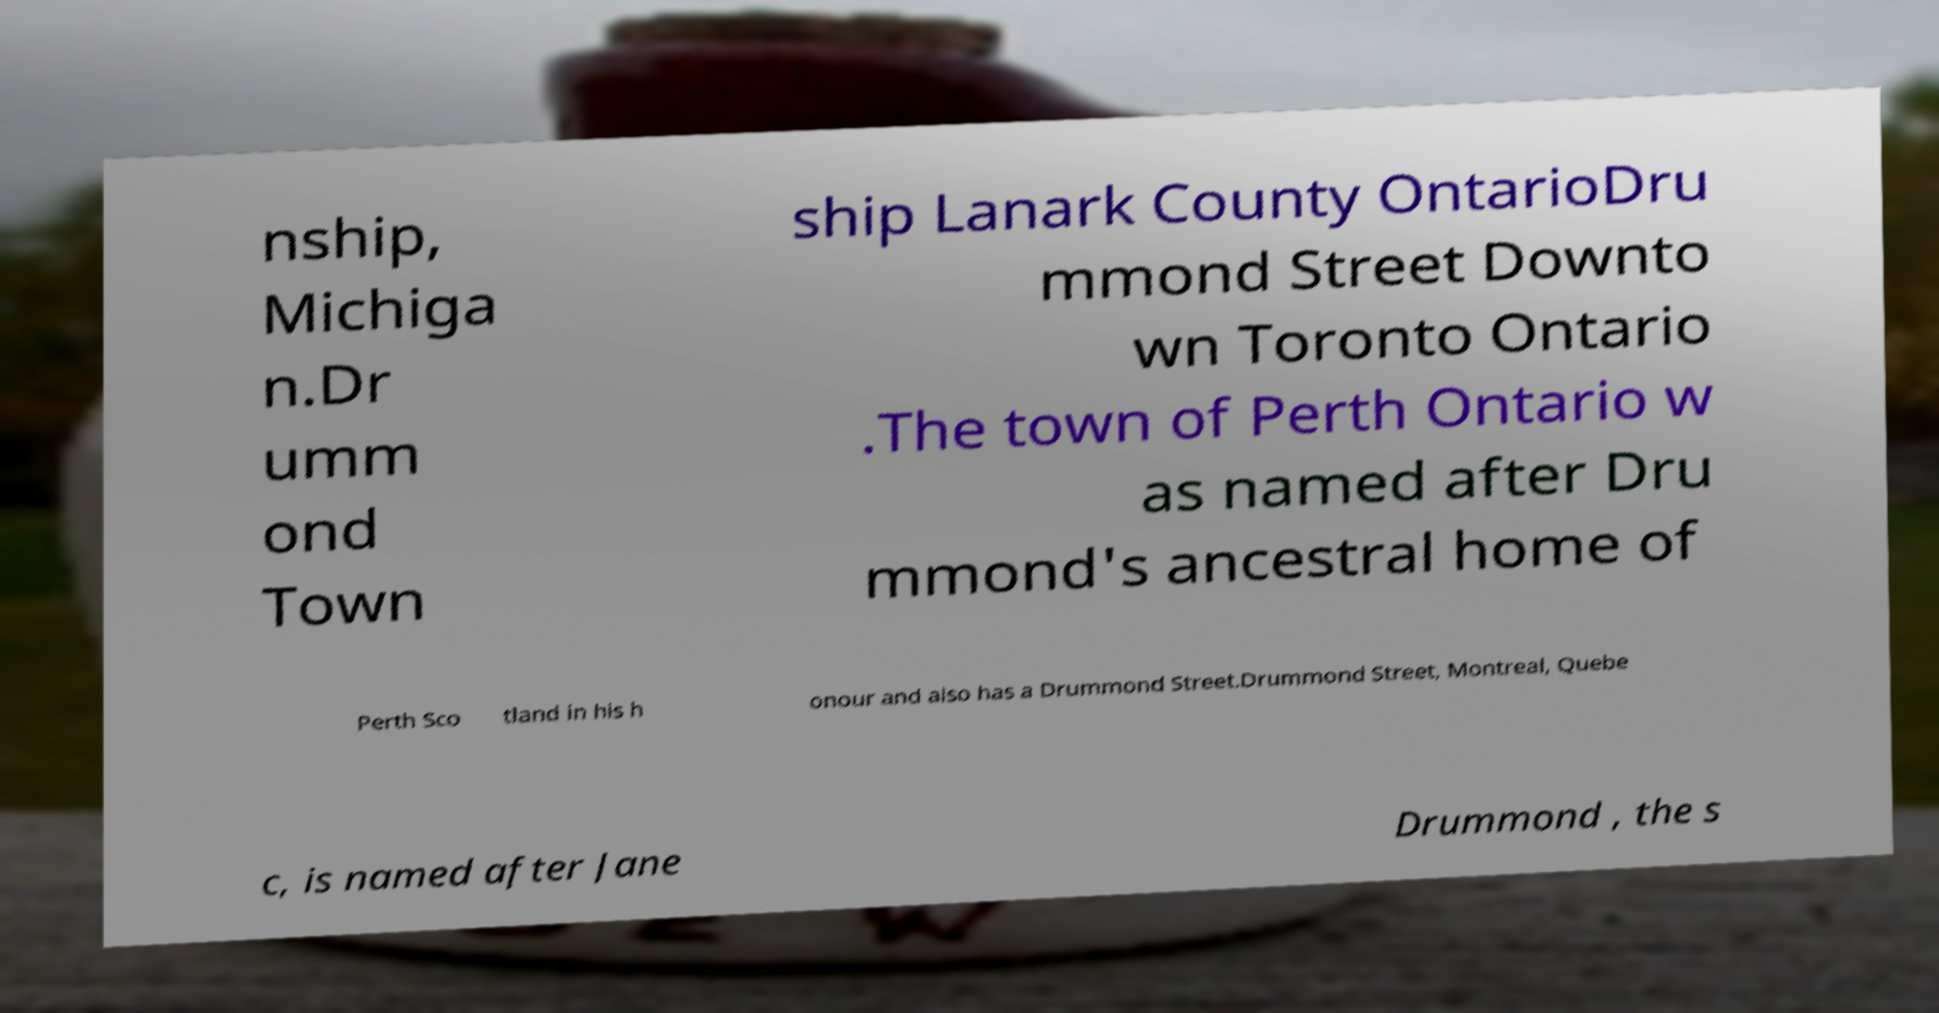Can you read and provide the text displayed in the image?This photo seems to have some interesting text. Can you extract and type it out for me? nship, Michiga n.Dr umm ond Town ship Lanark County OntarioDru mmond Street Downto wn Toronto Ontario .The town of Perth Ontario w as named after Dru mmond's ancestral home of Perth Sco tland in his h onour and also has a Drummond Street.Drummond Street, Montreal, Quebe c, is named after Jane Drummond , the s 